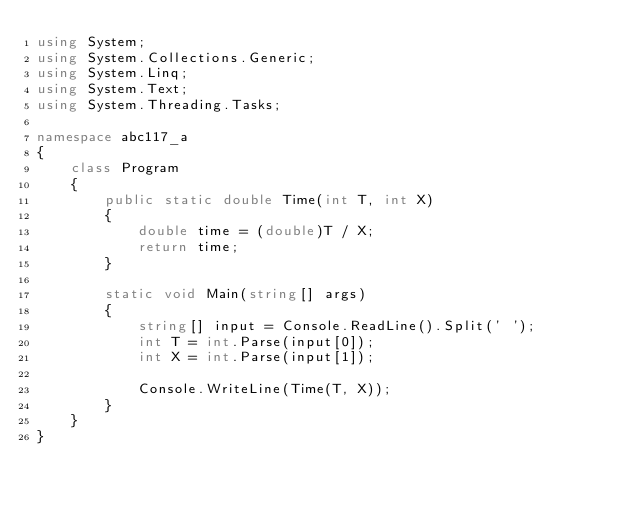Convert code to text. <code><loc_0><loc_0><loc_500><loc_500><_C#_>using System;
using System.Collections.Generic;
using System.Linq;
using System.Text;
using System.Threading.Tasks;

namespace abc117_a
{
    class Program
    {
        public static double Time(int T, int X)
        {
            double time = (double)T / X;
            return time;
        }

        static void Main(string[] args)
        {
            string[] input = Console.ReadLine().Split(' ');
            int T = int.Parse(input[0]);
            int X = int.Parse(input[1]);

            Console.WriteLine(Time(T, X));
        }
    }
}
</code> 